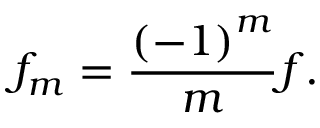Convert formula to latex. <formula><loc_0><loc_0><loc_500><loc_500>f _ { m } = \frac { \left ( - 1 \right ) ^ { m } } { m } f .</formula> 